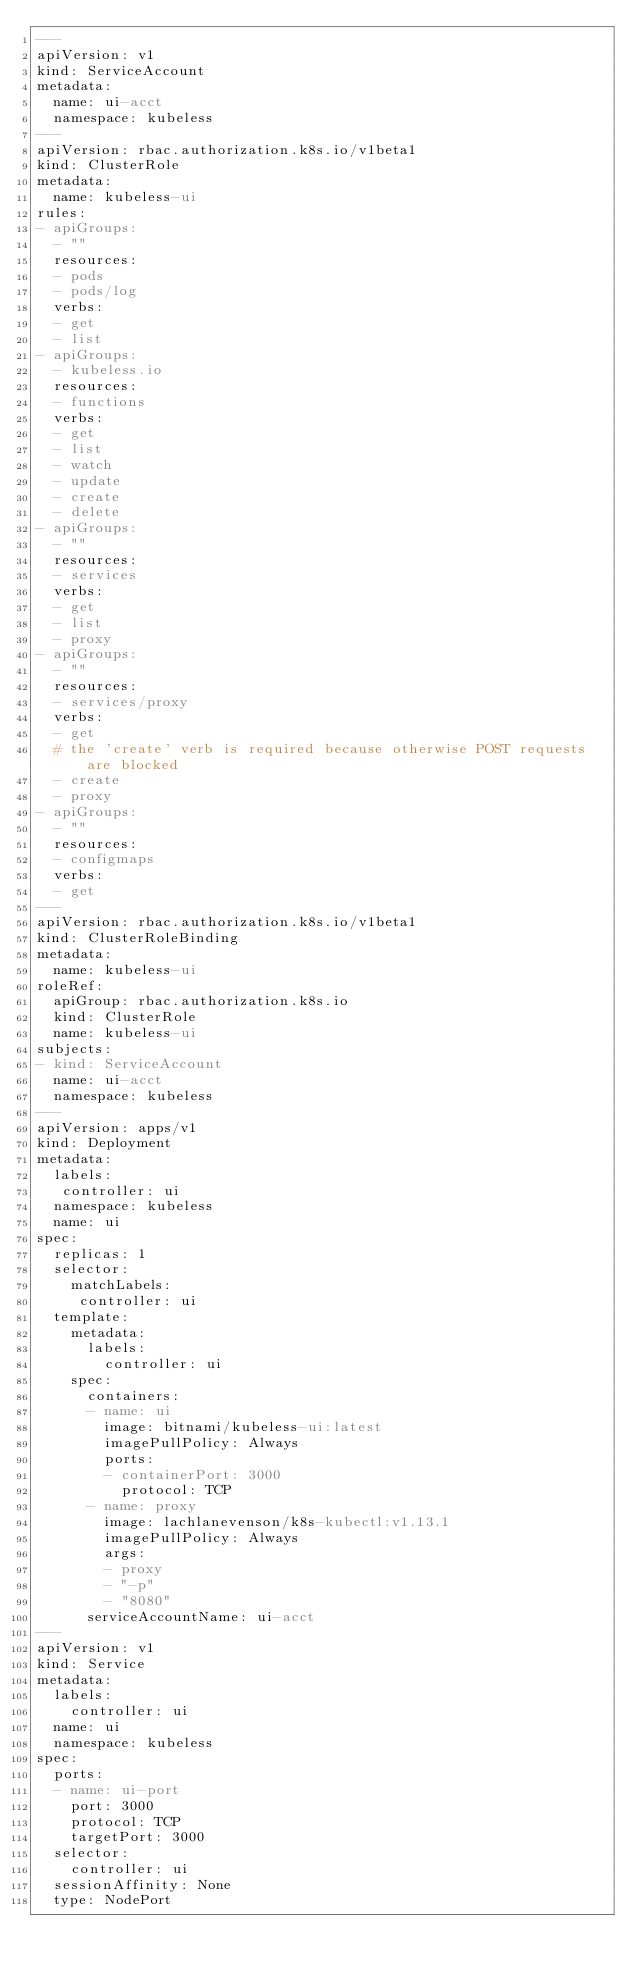<code> <loc_0><loc_0><loc_500><loc_500><_YAML_>---
apiVersion: v1
kind: ServiceAccount
metadata:
  name: ui-acct
  namespace: kubeless
---
apiVersion: rbac.authorization.k8s.io/v1beta1
kind: ClusterRole
metadata:
  name: kubeless-ui
rules:
- apiGroups:
  - ""
  resources:
  - pods
  - pods/log
  verbs:
  - get
  - list
- apiGroups:
  - kubeless.io
  resources:
  - functions
  verbs:
  - get
  - list
  - watch
  - update
  - create
  - delete
- apiGroups:
  - ""
  resources:
  - services
  verbs:
  - get
  - list
  - proxy
- apiGroups:
  - ""
  resources:
  - services/proxy
  verbs:
  - get
  # the 'create' verb is required because otherwise POST requests are blocked
  - create
  - proxy
- apiGroups:
  - ""
  resources:
  - configmaps
  verbs:
  - get
---
apiVersion: rbac.authorization.k8s.io/v1beta1
kind: ClusterRoleBinding
metadata:
  name: kubeless-ui
roleRef:
  apiGroup: rbac.authorization.k8s.io
  kind: ClusterRole
  name: kubeless-ui
subjects:
- kind: ServiceAccount
  name: ui-acct
  namespace: kubeless
---
apiVersion: apps/v1 
kind: Deployment
metadata:
  labels:
   controller: ui
  namespace: kubeless
  name: ui
spec:
  replicas: 1
  selector:
    matchLabels:
     controller: ui
  template:
    metadata:
      labels:
        controller: ui
    spec:
      containers:
      - name: ui
        image: bitnami/kubeless-ui:latest
        imagePullPolicy: Always
        ports:
        - containerPort: 3000
          protocol: TCP
      - name: proxy
        image: lachlanevenson/k8s-kubectl:v1.13.1
        imagePullPolicy: Always
        args:
        - proxy
        - "-p"
        - "8080"
      serviceAccountName: ui-acct
---
apiVersion: v1
kind: Service
metadata:
  labels:
    controller: ui
  name: ui
  namespace: kubeless
spec:
  ports:
  - name: ui-port
    port: 3000
    protocol: TCP
    targetPort: 3000
  selector:
    controller: ui
  sessionAffinity: None
  type: NodePort
</code> 